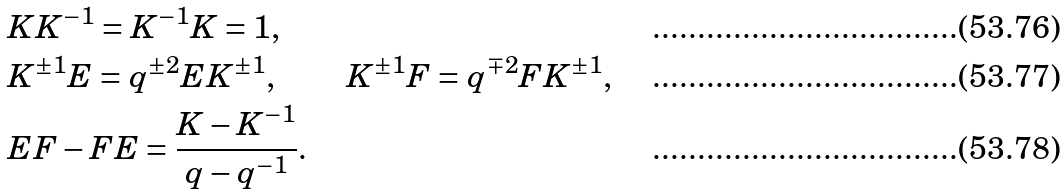<formula> <loc_0><loc_0><loc_500><loc_500>& K K ^ { - 1 } = K ^ { - 1 } K = 1 , & \\ & K ^ { \pm 1 } E = q ^ { \pm 2 } E K ^ { \pm 1 } , & K ^ { \pm 1 } F = q ^ { \mp 2 } F K ^ { \pm 1 } , \\ & E F - F E = \frac { K - K ^ { - 1 } } { q - q ^ { - 1 } } . &</formula> 